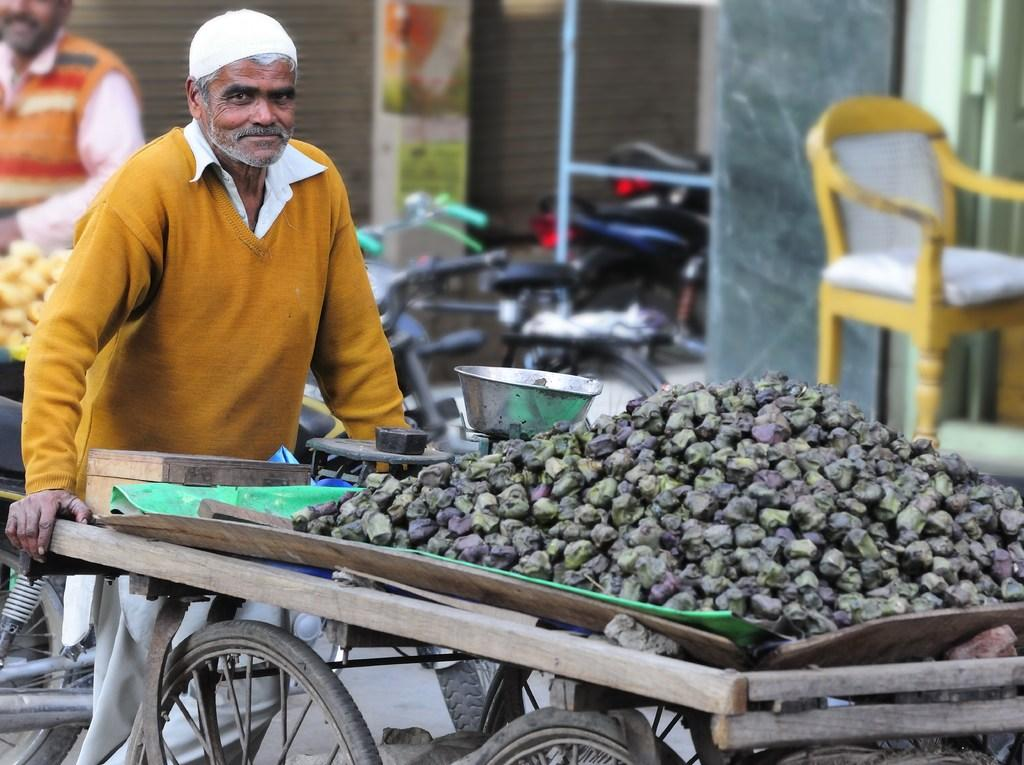What is the person in the image doing? The person is standing in the image. What is the person wearing on their head? The person is wearing a cap in the image. What object is the person holding? The person is holding a vegetable cart in the image. What can be seen in the background of the image? There is a bike and a chair in the background of the image. What type of pen is the person using to write on the trousers in the image? There is no pen or trousers present in the image. 